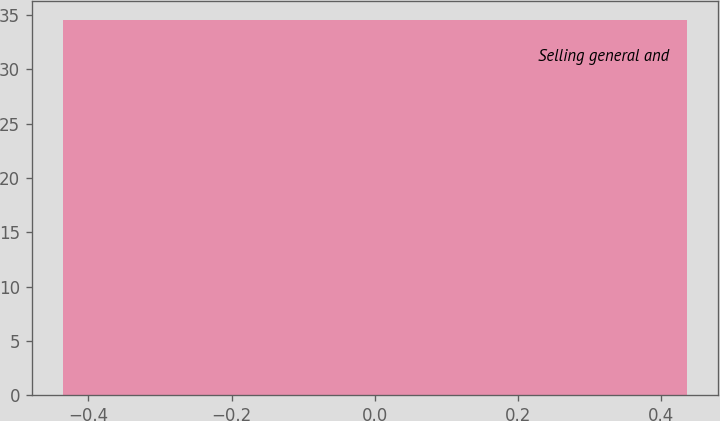<chart> <loc_0><loc_0><loc_500><loc_500><bar_chart><fcel>Selling general and<nl><fcel>34.6<nl></chart> 